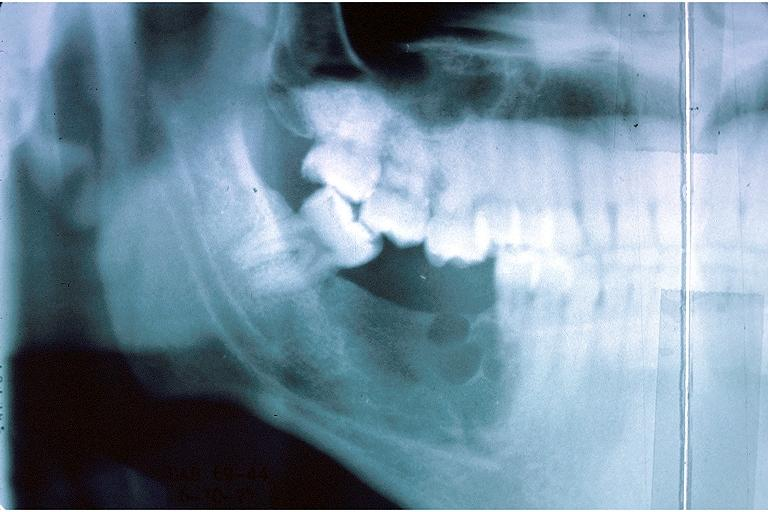what does this image show?
Answer the question using a single word or phrase. Ameloblastic fibroma 